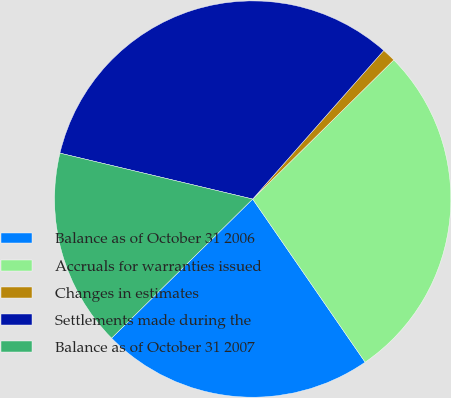Convert chart. <chart><loc_0><loc_0><loc_500><loc_500><pie_chart><fcel>Balance as of October 31 2006<fcel>Accruals for warranties issued<fcel>Changes in estimates<fcel>Settlements made during the<fcel>Balance as of October 31 2007<nl><fcel>22.22%<fcel>27.78%<fcel>1.11%<fcel>32.78%<fcel>16.11%<nl></chart> 